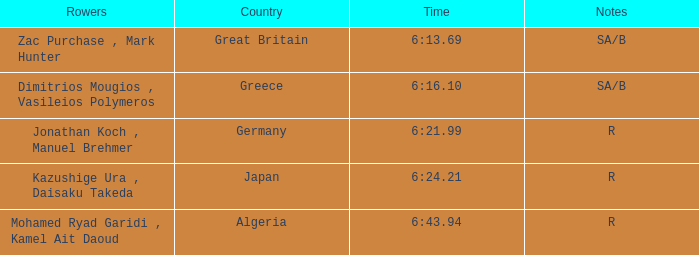What's the time of Rank 3? 6:21.99. 